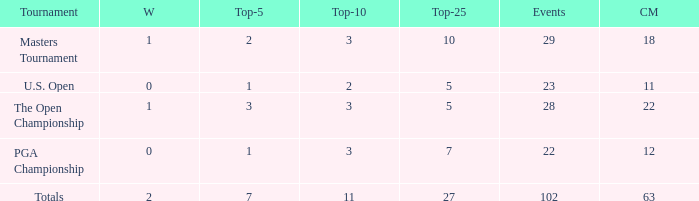How many vuts made for a player with 2 wins and under 7 top 5s? None. 